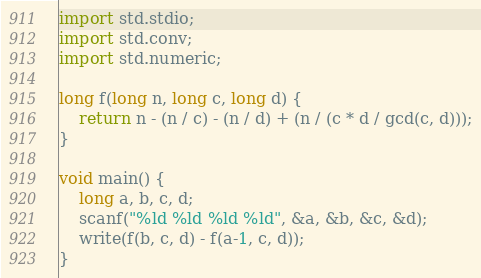<code> <loc_0><loc_0><loc_500><loc_500><_D_>import std.stdio;
import std.conv;
import std.numeric;

long f(long n, long c, long d) {
	return n - (n / c) - (n / d) + (n / (c * d / gcd(c, d)));
}

void main() {
	long a, b, c, d;
	scanf("%ld %ld %ld %ld", &a, &b, &c, &d);
	write(f(b, c, d) - f(a-1, c, d));
}
</code> 